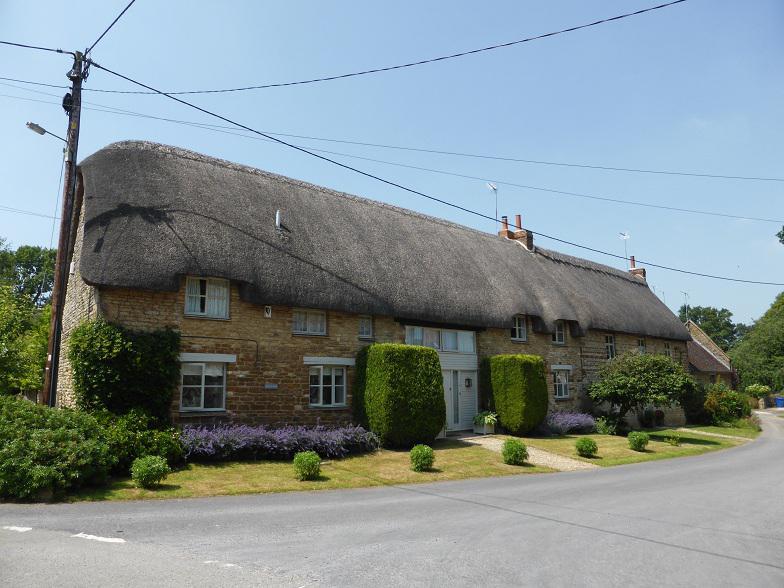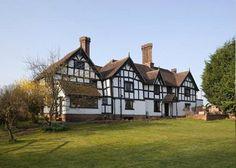The first image is the image on the left, the second image is the image on the right. Considering the images on both sides, is "Two buildings have second story windows." valid? Answer yes or no. Yes. The first image is the image on the left, the second image is the image on the right. Examine the images to the left and right. Is the description "The building in the image on the right is fenced in." accurate? Answer yes or no. No. 